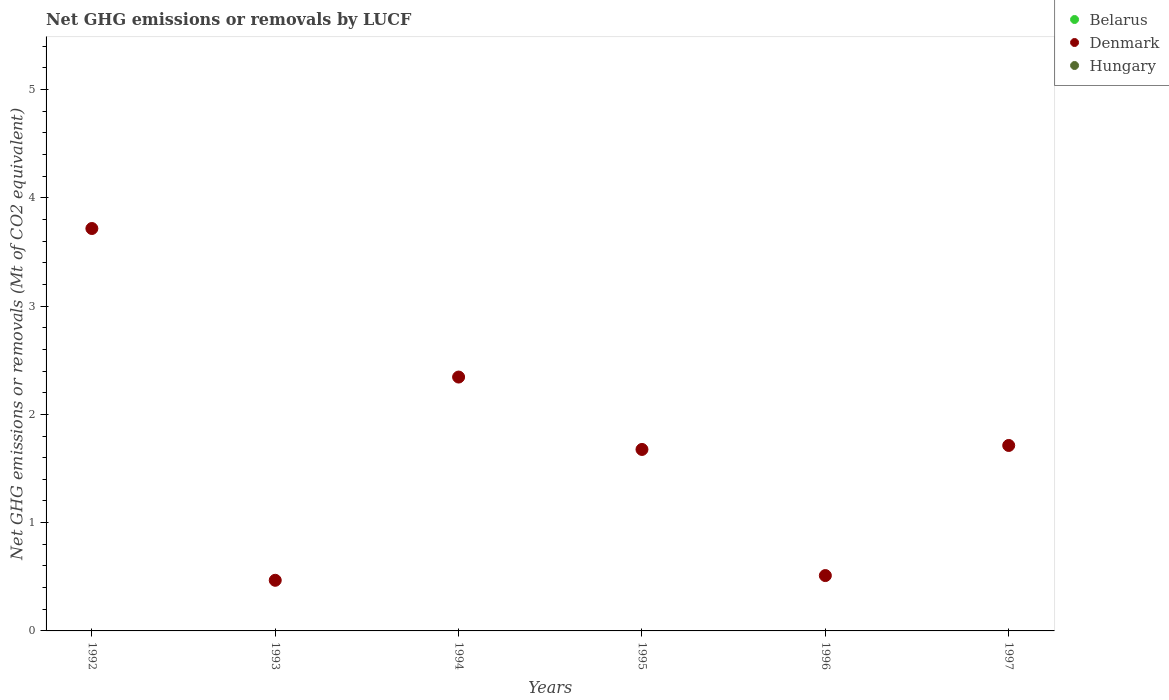How many different coloured dotlines are there?
Offer a terse response. 1. What is the net GHG emissions or removals by LUCF in Hungary in 1996?
Provide a succinct answer. 0. Across all years, what is the maximum net GHG emissions or removals by LUCF in Denmark?
Your answer should be compact. 3.72. Across all years, what is the minimum net GHG emissions or removals by LUCF in Hungary?
Offer a very short reply. 0. In which year was the net GHG emissions or removals by LUCF in Denmark maximum?
Offer a very short reply. 1992. What is the total net GHG emissions or removals by LUCF in Denmark in the graph?
Your response must be concise. 10.43. What is the difference between the net GHG emissions or removals by LUCF in Denmark in 1995 and that in 1996?
Offer a terse response. 1.16. What is the difference between the net GHG emissions or removals by LUCF in Denmark in 1994 and the net GHG emissions or removals by LUCF in Belarus in 1997?
Your answer should be compact. 2.34. What is the ratio of the net GHG emissions or removals by LUCF in Denmark in 1992 to that in 1994?
Keep it short and to the point. 1.59. Is the net GHG emissions or removals by LUCF in Denmark in 1994 less than that in 1995?
Your answer should be very brief. No. What is the difference between the highest and the second highest net GHG emissions or removals by LUCF in Denmark?
Your answer should be compact. 1.37. What is the difference between the highest and the lowest net GHG emissions or removals by LUCF in Denmark?
Offer a terse response. 3.25. In how many years, is the net GHG emissions or removals by LUCF in Denmark greater than the average net GHG emissions or removals by LUCF in Denmark taken over all years?
Make the answer very short. 2. Is the sum of the net GHG emissions or removals by LUCF in Denmark in 1993 and 1995 greater than the maximum net GHG emissions or removals by LUCF in Hungary across all years?
Provide a succinct answer. Yes. Does the net GHG emissions or removals by LUCF in Denmark monotonically increase over the years?
Your answer should be very brief. No. Is the net GHG emissions or removals by LUCF in Denmark strictly greater than the net GHG emissions or removals by LUCF in Belarus over the years?
Your response must be concise. Yes. How many years are there in the graph?
Provide a succinct answer. 6. Are the values on the major ticks of Y-axis written in scientific E-notation?
Your answer should be compact. No. Does the graph contain any zero values?
Your answer should be compact. Yes. Where does the legend appear in the graph?
Give a very brief answer. Top right. How are the legend labels stacked?
Provide a succinct answer. Vertical. What is the title of the graph?
Offer a very short reply. Net GHG emissions or removals by LUCF. Does "Bulgaria" appear as one of the legend labels in the graph?
Ensure brevity in your answer.  No. What is the label or title of the Y-axis?
Offer a very short reply. Net GHG emissions or removals (Mt of CO2 equivalent). What is the Net GHG emissions or removals (Mt of CO2 equivalent) in Belarus in 1992?
Keep it short and to the point. 0. What is the Net GHG emissions or removals (Mt of CO2 equivalent) in Denmark in 1992?
Your answer should be very brief. 3.72. What is the Net GHG emissions or removals (Mt of CO2 equivalent) of Hungary in 1992?
Provide a succinct answer. 0. What is the Net GHG emissions or removals (Mt of CO2 equivalent) of Belarus in 1993?
Keep it short and to the point. 0. What is the Net GHG emissions or removals (Mt of CO2 equivalent) of Denmark in 1993?
Make the answer very short. 0.47. What is the Net GHG emissions or removals (Mt of CO2 equivalent) of Denmark in 1994?
Give a very brief answer. 2.34. What is the Net GHG emissions or removals (Mt of CO2 equivalent) in Hungary in 1994?
Make the answer very short. 0. What is the Net GHG emissions or removals (Mt of CO2 equivalent) of Belarus in 1995?
Provide a succinct answer. 0. What is the Net GHG emissions or removals (Mt of CO2 equivalent) in Denmark in 1995?
Make the answer very short. 1.68. What is the Net GHG emissions or removals (Mt of CO2 equivalent) of Hungary in 1995?
Offer a terse response. 0. What is the Net GHG emissions or removals (Mt of CO2 equivalent) in Denmark in 1996?
Give a very brief answer. 0.51. What is the Net GHG emissions or removals (Mt of CO2 equivalent) in Belarus in 1997?
Your response must be concise. 0. What is the Net GHG emissions or removals (Mt of CO2 equivalent) of Denmark in 1997?
Provide a succinct answer. 1.71. Across all years, what is the maximum Net GHG emissions or removals (Mt of CO2 equivalent) of Denmark?
Offer a very short reply. 3.72. Across all years, what is the minimum Net GHG emissions or removals (Mt of CO2 equivalent) in Denmark?
Provide a short and direct response. 0.47. What is the total Net GHG emissions or removals (Mt of CO2 equivalent) of Denmark in the graph?
Provide a short and direct response. 10.43. What is the total Net GHG emissions or removals (Mt of CO2 equivalent) in Hungary in the graph?
Keep it short and to the point. 0. What is the difference between the Net GHG emissions or removals (Mt of CO2 equivalent) in Denmark in 1992 and that in 1993?
Your answer should be compact. 3.25. What is the difference between the Net GHG emissions or removals (Mt of CO2 equivalent) in Denmark in 1992 and that in 1994?
Ensure brevity in your answer.  1.37. What is the difference between the Net GHG emissions or removals (Mt of CO2 equivalent) in Denmark in 1992 and that in 1995?
Give a very brief answer. 2.04. What is the difference between the Net GHG emissions or removals (Mt of CO2 equivalent) of Denmark in 1992 and that in 1996?
Your answer should be compact. 3.21. What is the difference between the Net GHG emissions or removals (Mt of CO2 equivalent) in Denmark in 1992 and that in 1997?
Your answer should be compact. 2. What is the difference between the Net GHG emissions or removals (Mt of CO2 equivalent) in Denmark in 1993 and that in 1994?
Provide a short and direct response. -1.88. What is the difference between the Net GHG emissions or removals (Mt of CO2 equivalent) of Denmark in 1993 and that in 1995?
Your answer should be compact. -1.21. What is the difference between the Net GHG emissions or removals (Mt of CO2 equivalent) of Denmark in 1993 and that in 1996?
Provide a succinct answer. -0.04. What is the difference between the Net GHG emissions or removals (Mt of CO2 equivalent) in Denmark in 1993 and that in 1997?
Your answer should be very brief. -1.25. What is the difference between the Net GHG emissions or removals (Mt of CO2 equivalent) of Denmark in 1994 and that in 1995?
Offer a terse response. 0.67. What is the difference between the Net GHG emissions or removals (Mt of CO2 equivalent) in Denmark in 1994 and that in 1996?
Provide a short and direct response. 1.83. What is the difference between the Net GHG emissions or removals (Mt of CO2 equivalent) in Denmark in 1994 and that in 1997?
Your response must be concise. 0.63. What is the difference between the Net GHG emissions or removals (Mt of CO2 equivalent) of Denmark in 1995 and that in 1996?
Offer a very short reply. 1.16. What is the difference between the Net GHG emissions or removals (Mt of CO2 equivalent) in Denmark in 1995 and that in 1997?
Ensure brevity in your answer.  -0.04. What is the difference between the Net GHG emissions or removals (Mt of CO2 equivalent) in Denmark in 1996 and that in 1997?
Provide a short and direct response. -1.2. What is the average Net GHG emissions or removals (Mt of CO2 equivalent) in Denmark per year?
Make the answer very short. 1.74. What is the average Net GHG emissions or removals (Mt of CO2 equivalent) of Hungary per year?
Offer a very short reply. 0. What is the ratio of the Net GHG emissions or removals (Mt of CO2 equivalent) of Denmark in 1992 to that in 1993?
Make the answer very short. 7.95. What is the ratio of the Net GHG emissions or removals (Mt of CO2 equivalent) of Denmark in 1992 to that in 1994?
Provide a succinct answer. 1.59. What is the ratio of the Net GHG emissions or removals (Mt of CO2 equivalent) in Denmark in 1992 to that in 1995?
Ensure brevity in your answer.  2.22. What is the ratio of the Net GHG emissions or removals (Mt of CO2 equivalent) in Denmark in 1992 to that in 1996?
Your answer should be very brief. 7.27. What is the ratio of the Net GHG emissions or removals (Mt of CO2 equivalent) in Denmark in 1992 to that in 1997?
Provide a succinct answer. 2.17. What is the ratio of the Net GHG emissions or removals (Mt of CO2 equivalent) of Denmark in 1993 to that in 1994?
Your response must be concise. 0.2. What is the ratio of the Net GHG emissions or removals (Mt of CO2 equivalent) of Denmark in 1993 to that in 1995?
Your answer should be very brief. 0.28. What is the ratio of the Net GHG emissions or removals (Mt of CO2 equivalent) in Denmark in 1993 to that in 1996?
Ensure brevity in your answer.  0.91. What is the ratio of the Net GHG emissions or removals (Mt of CO2 equivalent) of Denmark in 1993 to that in 1997?
Keep it short and to the point. 0.27. What is the ratio of the Net GHG emissions or removals (Mt of CO2 equivalent) of Denmark in 1994 to that in 1995?
Your answer should be compact. 1.4. What is the ratio of the Net GHG emissions or removals (Mt of CO2 equivalent) in Denmark in 1994 to that in 1996?
Your answer should be compact. 4.59. What is the ratio of the Net GHG emissions or removals (Mt of CO2 equivalent) of Denmark in 1994 to that in 1997?
Your response must be concise. 1.37. What is the ratio of the Net GHG emissions or removals (Mt of CO2 equivalent) of Denmark in 1995 to that in 1996?
Keep it short and to the point. 3.28. What is the ratio of the Net GHG emissions or removals (Mt of CO2 equivalent) of Denmark in 1995 to that in 1997?
Your answer should be very brief. 0.98. What is the ratio of the Net GHG emissions or removals (Mt of CO2 equivalent) of Denmark in 1996 to that in 1997?
Your response must be concise. 0.3. What is the difference between the highest and the second highest Net GHG emissions or removals (Mt of CO2 equivalent) in Denmark?
Offer a very short reply. 1.37. What is the difference between the highest and the lowest Net GHG emissions or removals (Mt of CO2 equivalent) of Denmark?
Give a very brief answer. 3.25. 